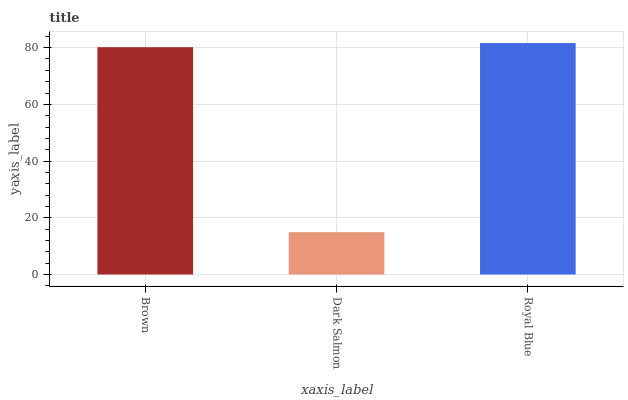Is Dark Salmon the minimum?
Answer yes or no. Yes. Is Royal Blue the maximum?
Answer yes or no. Yes. Is Royal Blue the minimum?
Answer yes or no. No. Is Dark Salmon the maximum?
Answer yes or no. No. Is Royal Blue greater than Dark Salmon?
Answer yes or no. Yes. Is Dark Salmon less than Royal Blue?
Answer yes or no. Yes. Is Dark Salmon greater than Royal Blue?
Answer yes or no. No. Is Royal Blue less than Dark Salmon?
Answer yes or no. No. Is Brown the high median?
Answer yes or no. Yes. Is Brown the low median?
Answer yes or no. Yes. Is Royal Blue the high median?
Answer yes or no. No. Is Royal Blue the low median?
Answer yes or no. No. 